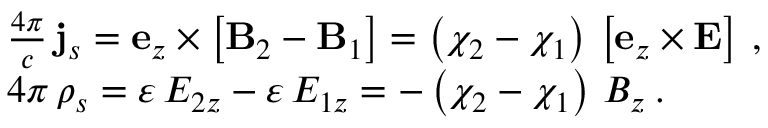Convert formula to latex. <formula><loc_0><loc_0><loc_500><loc_500>\begin{array} { r l } & { \frac { 4 \pi } { c } \, { j } _ { s } = { e } _ { z } \times \left [ { B } _ { 2 } - { B } _ { 1 } \right ] = \left ( \chi _ { 2 } - \chi _ { 1 } \right ) \, \left [ { e } _ { z } \times { E } \right ] \, , } \\ & { 4 \pi \, \rho _ { s } = \varepsilon \, E _ { 2 z } - \varepsilon \, E _ { 1 z } = - \left ( \chi _ { 2 } - \chi _ { 1 } \right ) \, B _ { z } \, . } \end{array}</formula> 